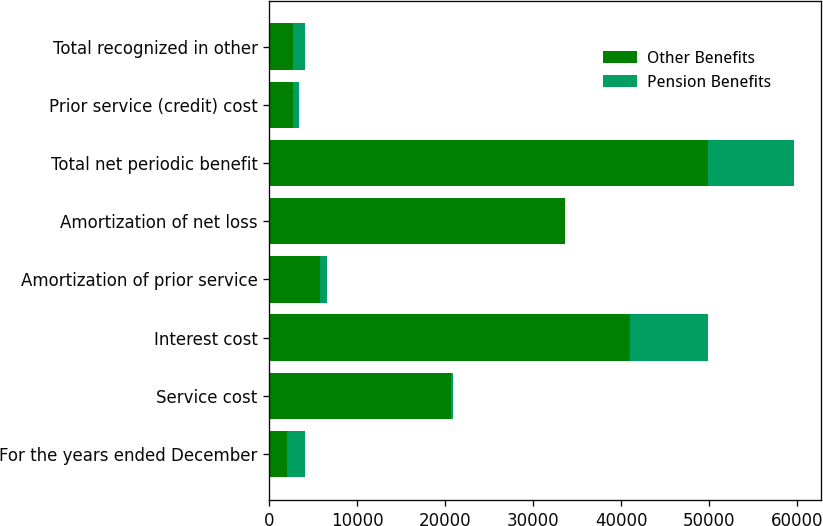Convert chart. <chart><loc_0><loc_0><loc_500><loc_500><stacked_bar_chart><ecel><fcel>For the years ended December<fcel>Service cost<fcel>Interest cost<fcel>Amortization of prior service<fcel>Amortization of net loss<fcel>Total net periodic benefit<fcel>Prior service (credit) cost<fcel>Total recognized in other<nl><fcel>Other Benefits<fcel>2017<fcel>20657<fcel>40996<fcel>5822<fcel>33648<fcel>49841<fcel>2650<fcel>2650<nl><fcel>Pension Benefits<fcel>2017<fcel>263<fcel>8837<fcel>748<fcel>1<fcel>9847<fcel>744<fcel>1395<nl></chart> 